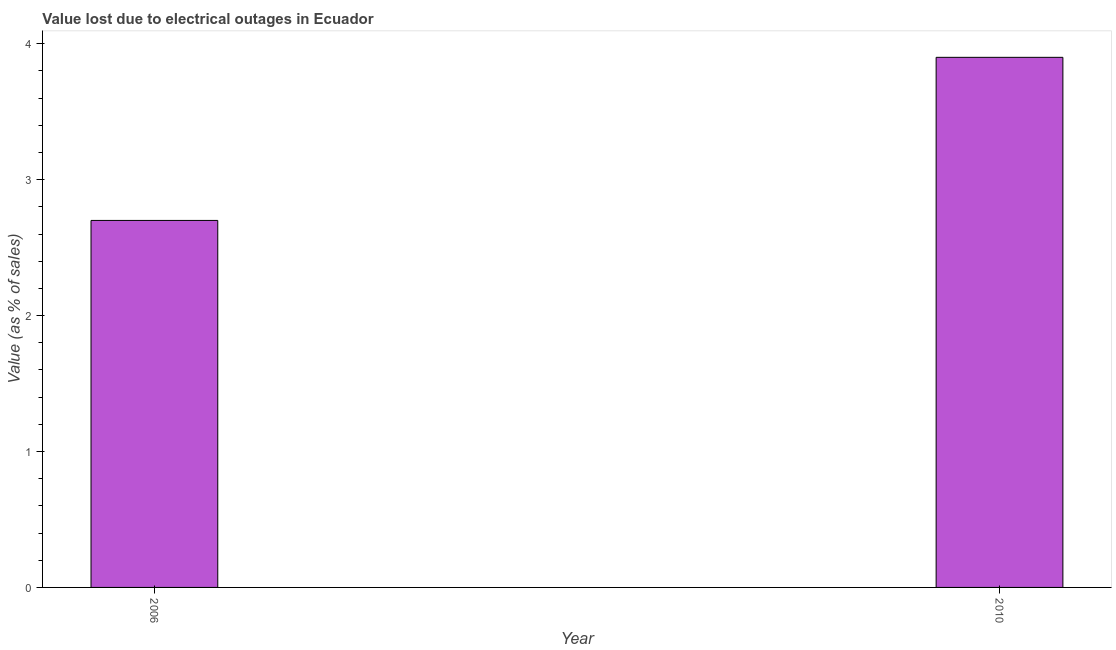Does the graph contain any zero values?
Make the answer very short. No. Does the graph contain grids?
Give a very brief answer. No. What is the title of the graph?
Offer a terse response. Value lost due to electrical outages in Ecuador. What is the label or title of the Y-axis?
Keep it short and to the point. Value (as % of sales). What is the value lost due to electrical outages in 2006?
Your response must be concise. 2.7. What is the sum of the value lost due to electrical outages?
Provide a short and direct response. 6.6. What is the difference between the value lost due to electrical outages in 2006 and 2010?
Offer a very short reply. -1.2. What is the ratio of the value lost due to electrical outages in 2006 to that in 2010?
Your answer should be compact. 0.69. How many years are there in the graph?
Give a very brief answer. 2. What is the difference between the Value (as % of sales) in 2006 and 2010?
Provide a succinct answer. -1.2. What is the ratio of the Value (as % of sales) in 2006 to that in 2010?
Offer a terse response. 0.69. 